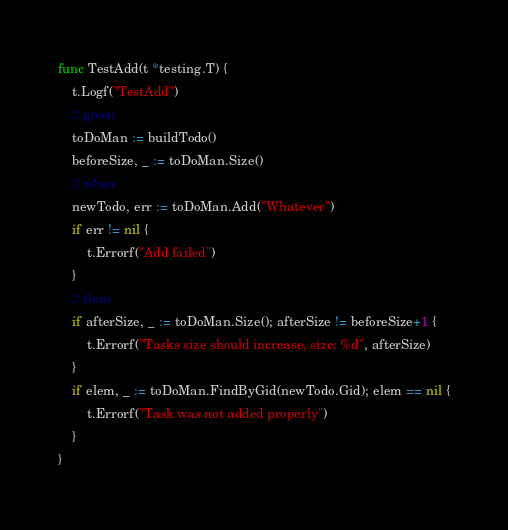Convert code to text. <code><loc_0><loc_0><loc_500><loc_500><_Go_>func TestAdd(t *testing.T) {
	t.Logf("TestAdd")
	// given
	toDoMan := buildTodo()
	beforeSize, _ := toDoMan.Size()
	// when
	newTodo, err := toDoMan.Add("Whatever")
	if err != nil {
		t.Errorf("Add failed")
	}
	// then
	if afterSize, _ := toDoMan.Size(); afterSize != beforeSize+1 {
		t.Errorf("Tasks size should increase, size: %d", afterSize)
	}
	if elem, _ := toDoMan.FindByGid(newTodo.Gid); elem == nil {
		t.Errorf("Task was not added properly")
	}
}
</code> 